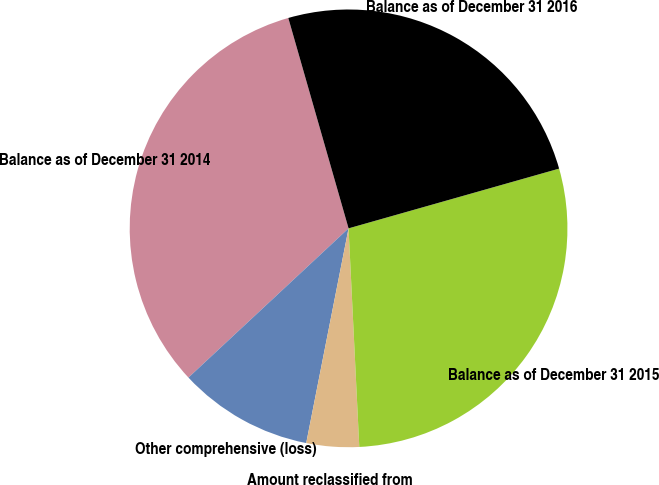Convert chart to OTSL. <chart><loc_0><loc_0><loc_500><loc_500><pie_chart><fcel>Balance as of December 31 2014<fcel>Other comprehensive (loss)<fcel>Amount reclassified from<fcel>Balance as of December 31 2015<fcel>Balance as of December 31 2016<nl><fcel>32.5%<fcel>9.96%<fcel>3.88%<fcel>28.62%<fcel>25.04%<nl></chart> 